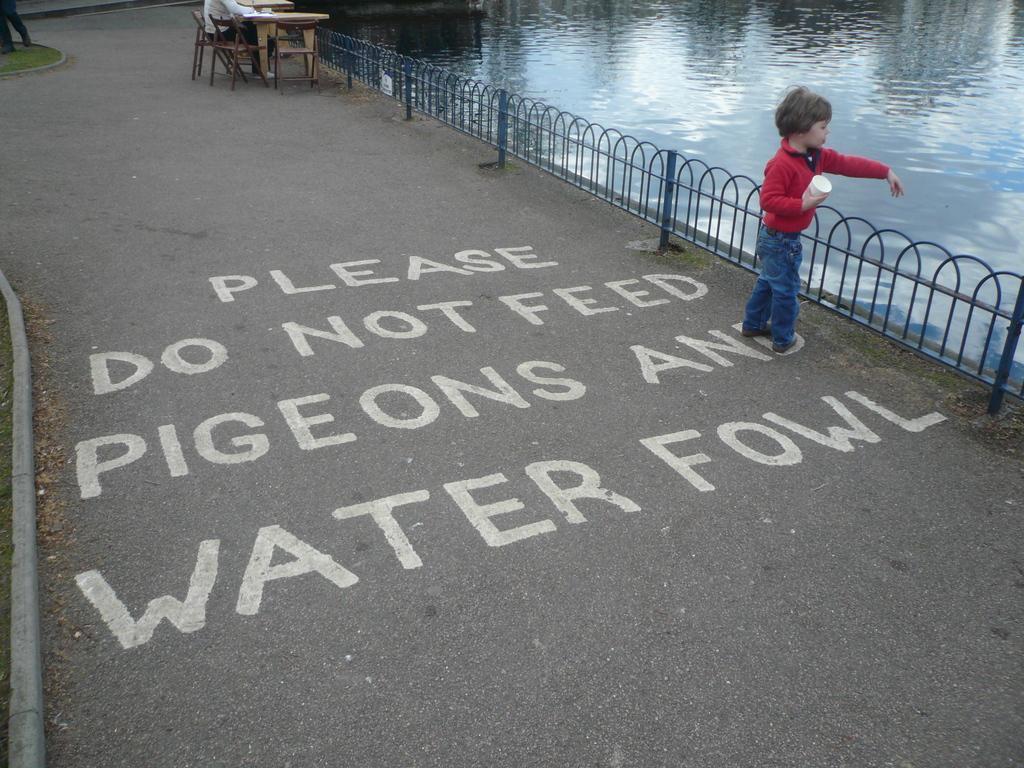How would you summarize this image in a sentence or two? In this picture we can see rode side of the road one boy standing and he is holding a cup in front of the boy there is a water lake and back side we can see some chairs and table one person is sitting on that chair. 